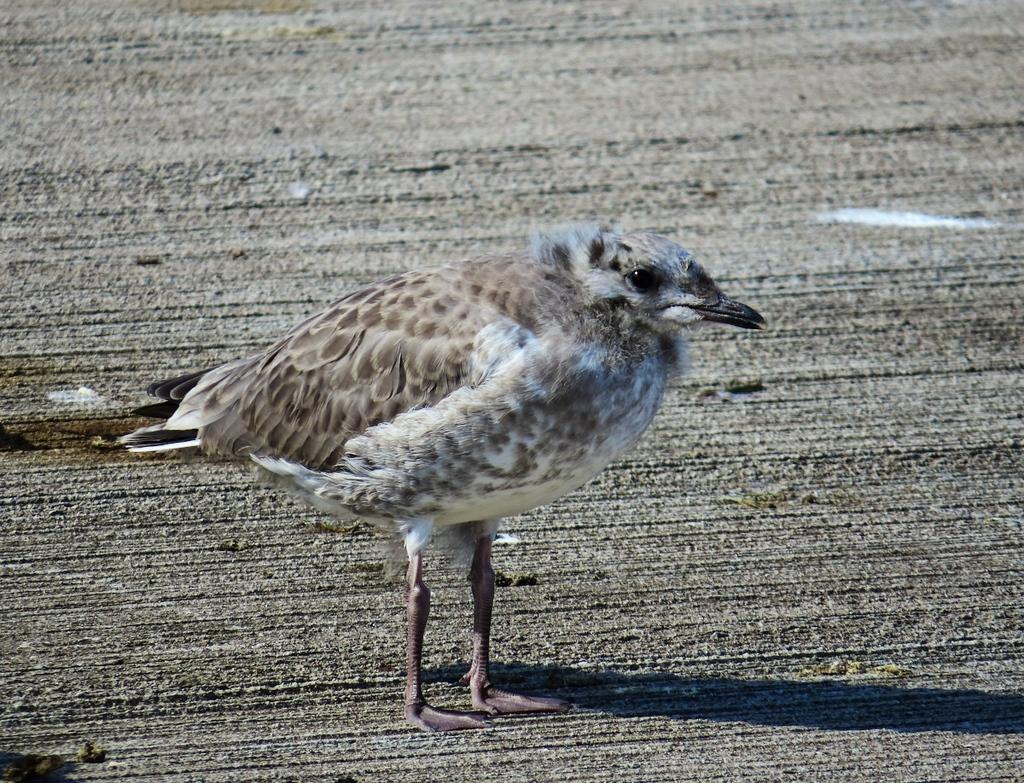What type of animal can be seen in the image? There is a bird in the image. What is the bird doing in the image? The bird is standing in the image. What color is the bird in the image? The bird is brown in color. What type of shirt is the bird wearing in the image? Birds do not wear shirts, so there is no shirt present in the image. 